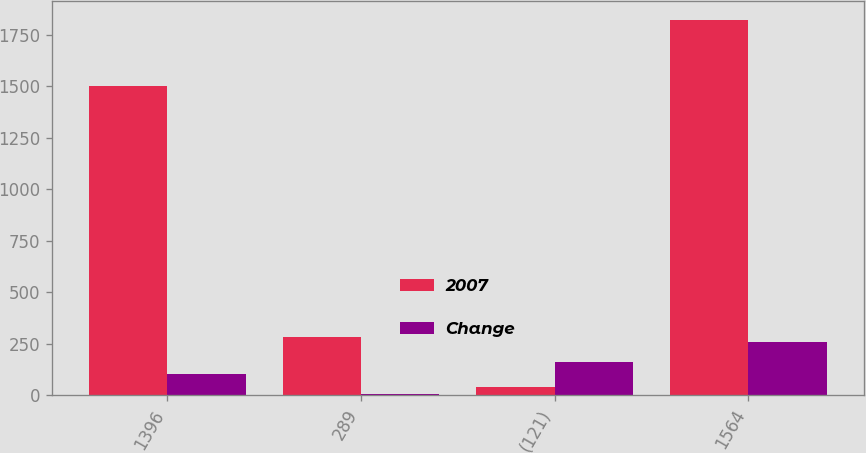Convert chart to OTSL. <chart><loc_0><loc_0><loc_500><loc_500><stacked_bar_chart><ecel><fcel>1396<fcel>289<fcel>(121)<fcel>1564<nl><fcel>2007<fcel>1502<fcel>281<fcel>41<fcel>1824<nl><fcel>Change<fcel>106<fcel>8<fcel>162<fcel>260<nl></chart> 